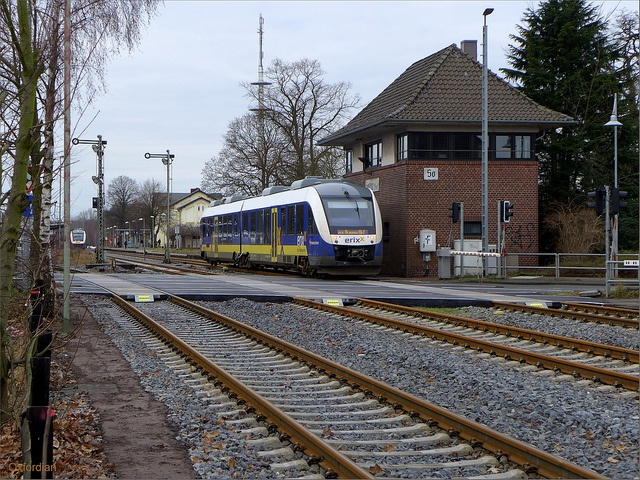Describe the objects in this image and their specific colors. I can see train in gray, black, lightgray, and navy tones, traffic light in gray and black tones, traffic light in gray, black, navy, and darkgray tones, traffic light in gray, black, and darkgreen tones, and traffic light in gray and black tones in this image. 